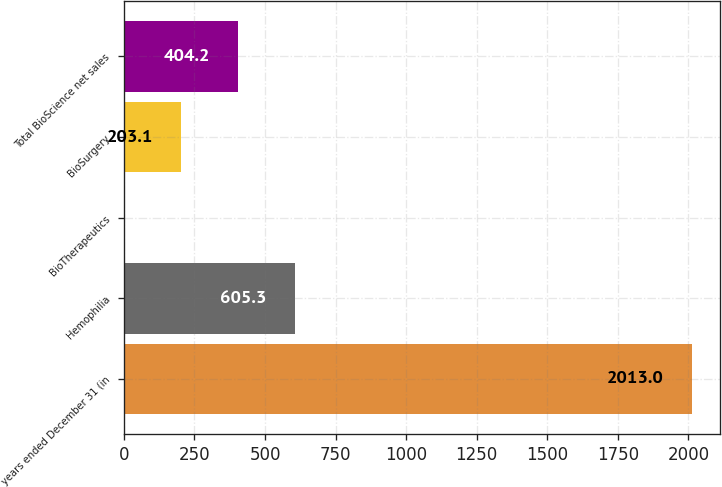<chart> <loc_0><loc_0><loc_500><loc_500><bar_chart><fcel>years ended December 31 (in<fcel>Hemophilia<fcel>BioTherapeutics<fcel>BioSurgery<fcel>Total BioScience net sales<nl><fcel>2013<fcel>605.3<fcel>2<fcel>203.1<fcel>404.2<nl></chart> 